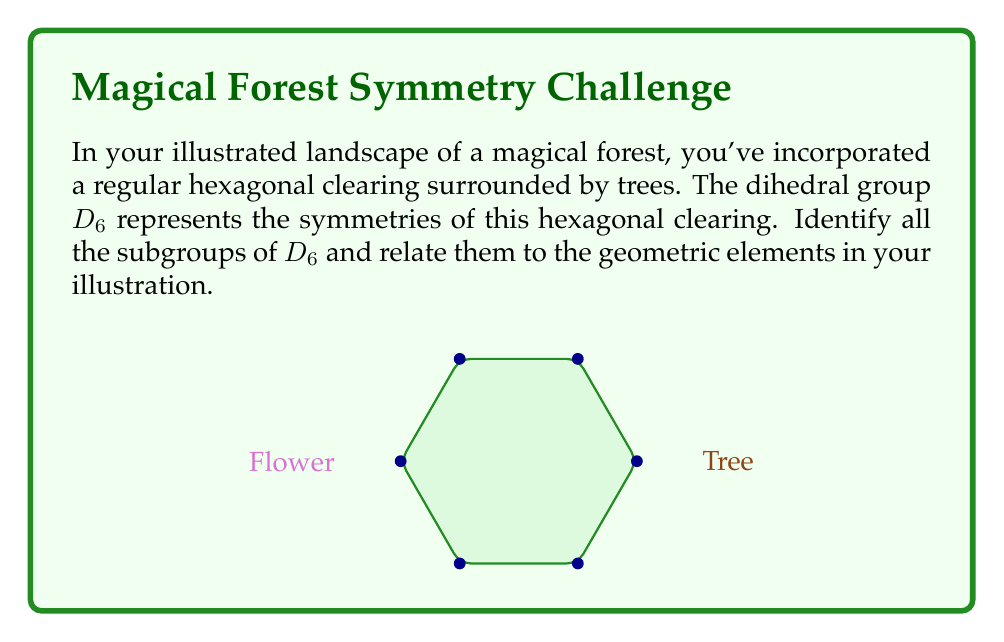Teach me how to tackle this problem. Let's approach this step-by-step:

1) First, recall that $D_6$ has 12 elements: 6 rotations (including the identity) and 6 reflections.

2) The rotations form a cyclic subgroup of order 6, which we can call $C_6$. This represents the rotational symmetry of the hexagonal clearing.

3) There are also cyclic subgroups of order 3 ($C_3$) and order 2 ($C_2$):
   - $C_3$ represents rotations by 120° and 240°
   - $C_2$ represents a 180° rotation

4) Each reflection axis forms a subgroup of order 2 with the identity. There are 6 such subgroups, each representing a line of symmetry in the hexagon.

5) The combination of a 180° rotation with reflections over two perpendicular axes forms a subgroup isomorphic to $D_2$ (Klein four-group).

6) Finally, there's the trivial subgroup containing only the identity element.

In total, $D_6$ has 15 subgroups:
- 1 subgroup of order 12 (D_6 itself)
- 1 subgroup of order 6 (C_6)
- 1 subgroup of order 3 (C_3)
- 7 subgroups of order 2 (6 reflection subgroups and C_2)
- 4 subgroups of order 4 (D_2)
- 1 trivial subgroup

These subgroups can be related to elements in your illustration:
- C_6: Full rotational symmetry of the clearing
- C_3: Rotational symmetry of triangular flower arrangements
- C_2: Symmetry between opposite trees or flowers
- Reflection subgroups: Axes of symmetry through pairs of opposite vertices or edges
- D_2: Symmetry of rectangular elements in the landscape
Answer: 15 subgroups: $D_6$, $C_6$, $C_3$, 6 reflection subgroups, $C_2$, 4 $D_2$, and the trivial subgroup. 